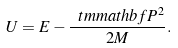<formula> <loc_0><loc_0><loc_500><loc_500>U = E - \frac { \ t m m a t h b f { P } ^ { 2 } } { 2 M } .</formula> 